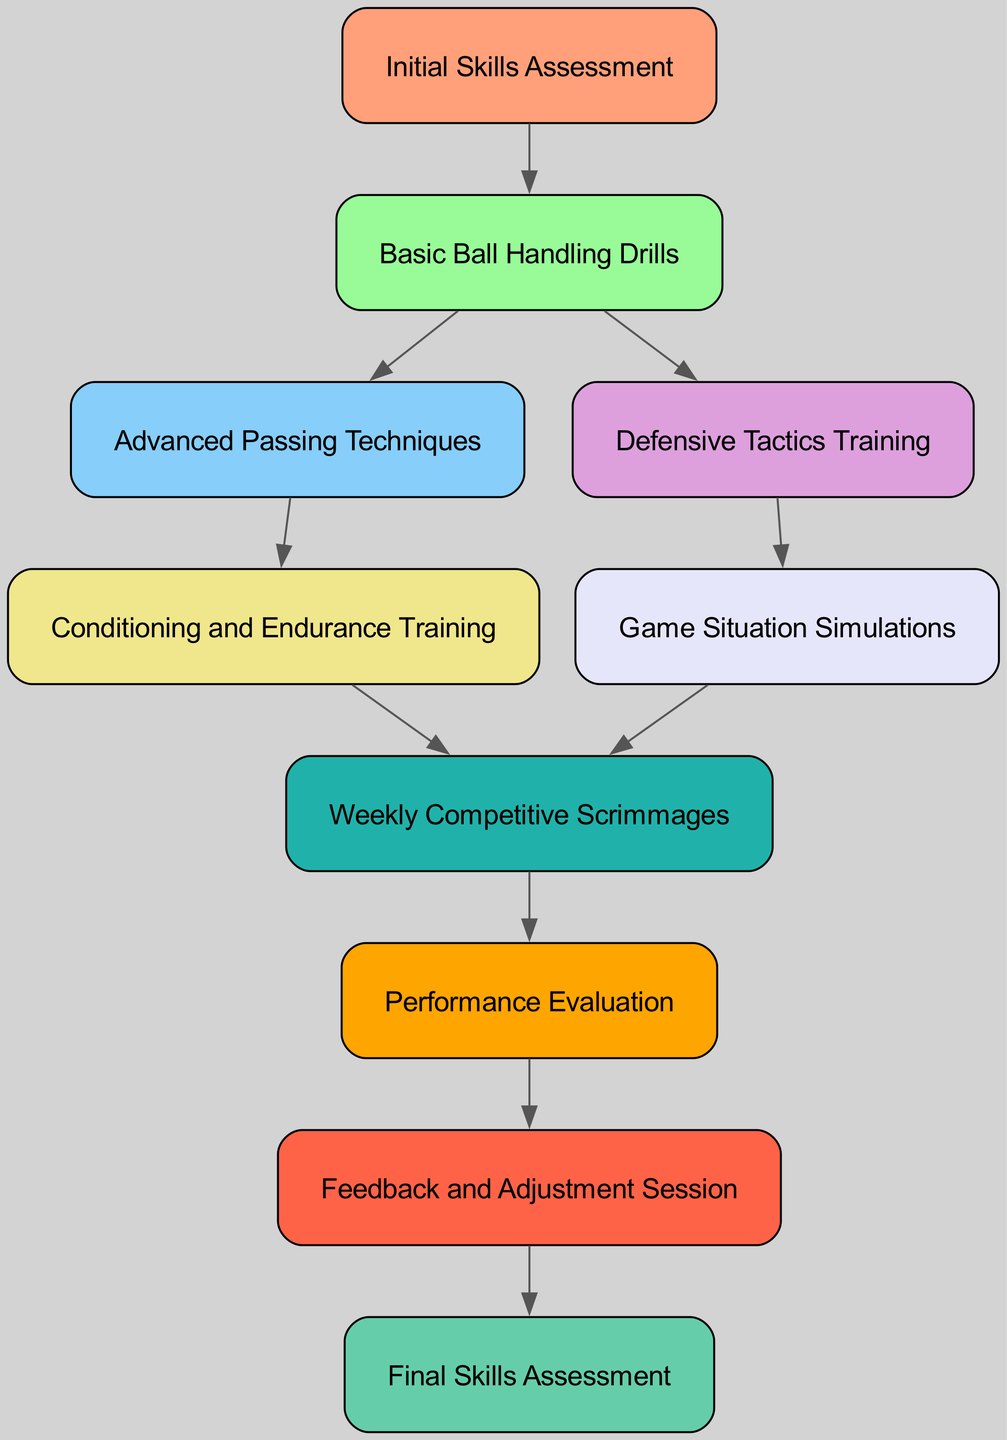What is the first node in the progression? The first node in the progression is labeled "Initial Skills Assessment," which is the starting point of the directed graph flow.
Answer: Initial Skills Assessment How many nodes are in the diagram? Counting all unique nodes listed in the data, there are a total of 10 nodes representing different stages of skills development.
Answer: 10 What follows "Basic Ball Handling Drills"? According to the edges, "Basic Ball Handling Drills" leads to both "Advanced Passing Techniques" and "Defensive Tactics Training," indicating the next skills to be developed.
Answer: Advanced Passing Techniques and Defensive Tactics Training Which node comes right before the "Final Skills Assessment"? The node that precedes "Final Skills Assessment" is "Feedback and Adjustment Session," as indicated by the directed edge showing their sequence.
Answer: Feedback and Adjustment Session What is the last node in the progression? The last node in the progression of the diagram is "Final Skills Assessment," which represents the culmination of the skill development process after all training and evaluations.
Answer: Final Skills Assessment How many edges are present in this directed graph? By counting the connections between nodes, there are a total of 9 edges indicating the directional flow from one skill development area to the next.
Answer: 9 Which nodes are associated with "Game Situation Simulations"? The directed graph shows that "Game Situation Simulations" is connected to "Defensive Tactics Training" and "Weekly Competitive Scrimmages," indicating its role in the skills development journey.
Answer: Defensive Tactics Training and Weekly Competitive Scrimmages What is the relationship between the "Performance Evaluation" and "Feedback and Adjustment Session"? "Performance Evaluation" has a direct connection leading to "Feedback and Adjustment Session," indicating that feedback is based on the player's performance assessment.
Answer: Feedback is based on performance assessment 